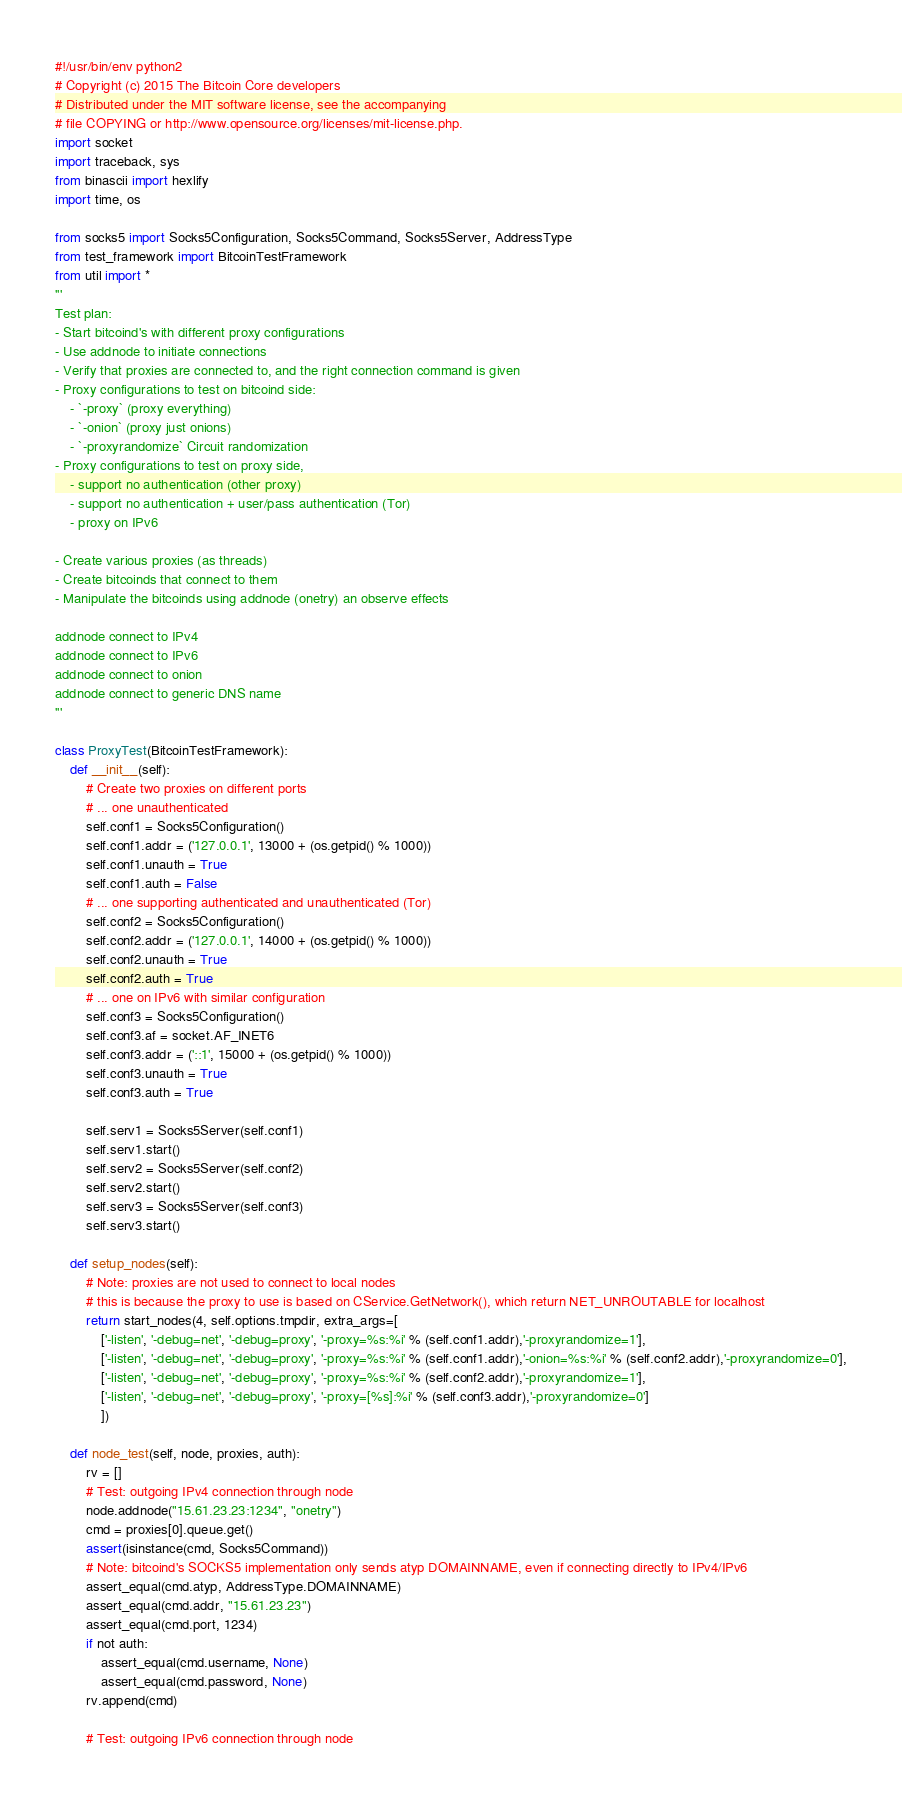Convert code to text. <code><loc_0><loc_0><loc_500><loc_500><_Python_>#!/usr/bin/env python2
# Copyright (c) 2015 The Bitcoin Core developers
# Distributed under the MIT software license, see the accompanying
# file COPYING or http://www.opensource.org/licenses/mit-license.php.
import socket
import traceback, sys
from binascii import hexlify
import time, os

from socks5 import Socks5Configuration, Socks5Command, Socks5Server, AddressType
from test_framework import BitcoinTestFramework
from util import *
'''
Test plan:
- Start bitcoind's with different proxy configurations
- Use addnode to initiate connections
- Verify that proxies are connected to, and the right connection command is given
- Proxy configurations to test on bitcoind side:
    - `-proxy` (proxy everything)
    - `-onion` (proxy just onions)
    - `-proxyrandomize` Circuit randomization
- Proxy configurations to test on proxy side,
    - support no authentication (other proxy)
    - support no authentication + user/pass authentication (Tor)
    - proxy on IPv6

- Create various proxies (as threads)
- Create bitcoinds that connect to them
- Manipulate the bitcoinds using addnode (onetry) an observe effects

addnode connect to IPv4
addnode connect to IPv6
addnode connect to onion
addnode connect to generic DNS name
'''

class ProxyTest(BitcoinTestFramework):
    def __init__(self):
        # Create two proxies on different ports
        # ... one unauthenticated
        self.conf1 = Socks5Configuration()
        self.conf1.addr = ('127.0.0.1', 13000 + (os.getpid() % 1000))
        self.conf1.unauth = True
        self.conf1.auth = False
        # ... one supporting authenticated and unauthenticated (Tor)
        self.conf2 = Socks5Configuration()
        self.conf2.addr = ('127.0.0.1', 14000 + (os.getpid() % 1000))
        self.conf2.unauth = True
        self.conf2.auth = True
        # ... one on IPv6 with similar configuration
        self.conf3 = Socks5Configuration()
        self.conf3.af = socket.AF_INET6
        self.conf3.addr = ('::1', 15000 + (os.getpid() % 1000))
        self.conf3.unauth = True
        self.conf3.auth = True

        self.serv1 = Socks5Server(self.conf1)
        self.serv1.start()
        self.serv2 = Socks5Server(self.conf2)
        self.serv2.start()
        self.serv3 = Socks5Server(self.conf3)
        self.serv3.start()

    def setup_nodes(self):
        # Note: proxies are not used to connect to local nodes
        # this is because the proxy to use is based on CService.GetNetwork(), which return NET_UNROUTABLE for localhost
        return start_nodes(4, self.options.tmpdir, extra_args=[
            ['-listen', '-debug=net', '-debug=proxy', '-proxy=%s:%i' % (self.conf1.addr),'-proxyrandomize=1'],
            ['-listen', '-debug=net', '-debug=proxy', '-proxy=%s:%i' % (self.conf1.addr),'-onion=%s:%i' % (self.conf2.addr),'-proxyrandomize=0'],
            ['-listen', '-debug=net', '-debug=proxy', '-proxy=%s:%i' % (self.conf2.addr),'-proxyrandomize=1'],
            ['-listen', '-debug=net', '-debug=proxy', '-proxy=[%s]:%i' % (self.conf3.addr),'-proxyrandomize=0']
            ])

    def node_test(self, node, proxies, auth):
        rv = []
        # Test: outgoing IPv4 connection through node
        node.addnode("15.61.23.23:1234", "onetry")
        cmd = proxies[0].queue.get()
        assert(isinstance(cmd, Socks5Command))
        # Note: bitcoind's SOCKS5 implementation only sends atyp DOMAINNAME, even if connecting directly to IPv4/IPv6
        assert_equal(cmd.atyp, AddressType.DOMAINNAME)
        assert_equal(cmd.addr, "15.61.23.23")
        assert_equal(cmd.port, 1234)
        if not auth:
            assert_equal(cmd.username, None)
            assert_equal(cmd.password, None)
        rv.append(cmd)

        # Test: outgoing IPv6 connection through node</code> 